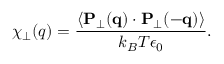<formula> <loc_0><loc_0><loc_500><loc_500>\chi _ { \perp } ( q ) = \frac { \langle { P } _ { \perp } ( { q } ) \cdot { P } _ { \perp } ( { - q } ) \rangle } { k _ { B } T \epsilon _ { 0 } } .</formula> 